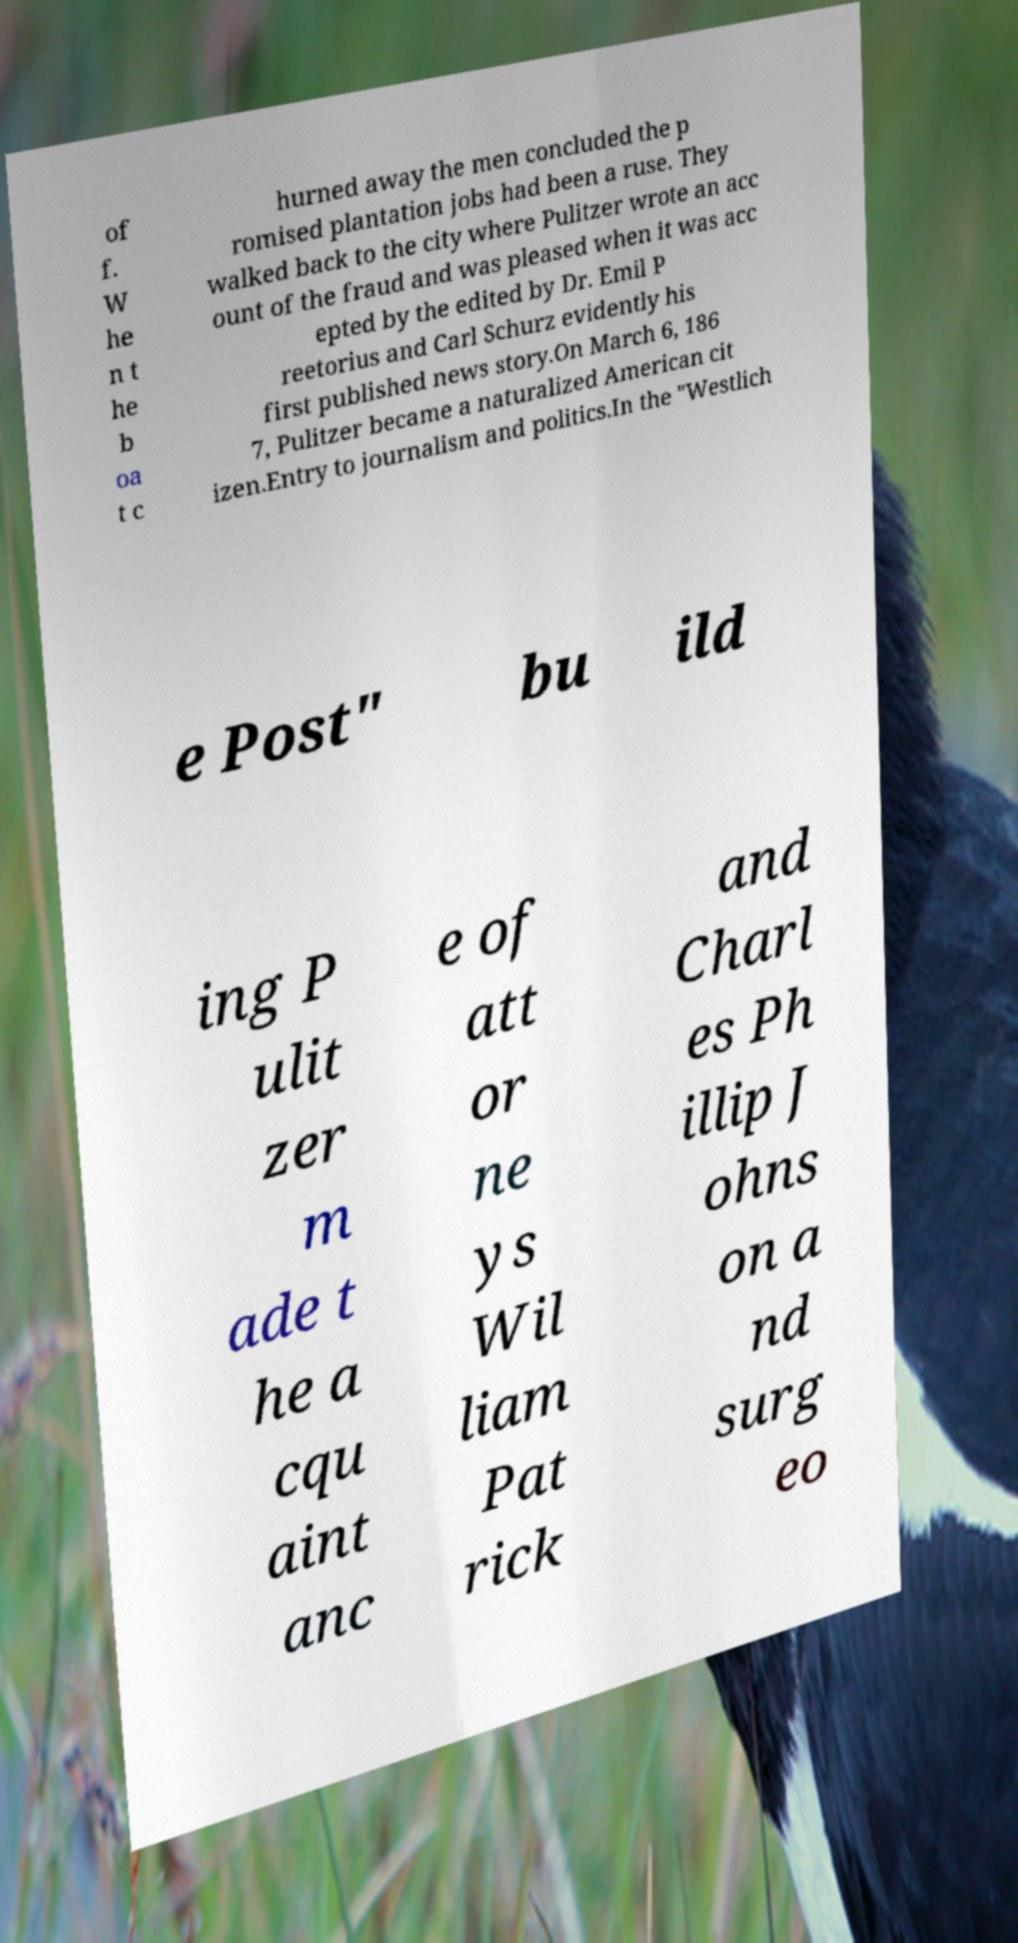Could you extract and type out the text from this image? of f. W he n t he b oa t c hurned away the men concluded the p romised plantation jobs had been a ruse. They walked back to the city where Pulitzer wrote an acc ount of the fraud and was pleased when it was acc epted by the edited by Dr. Emil P reetorius and Carl Schurz evidently his first published news story.On March 6, 186 7, Pulitzer became a naturalized American cit izen.Entry to journalism and politics.In the "Westlich e Post" bu ild ing P ulit zer m ade t he a cqu aint anc e of att or ne ys Wil liam Pat rick and Charl es Ph illip J ohns on a nd surg eo 